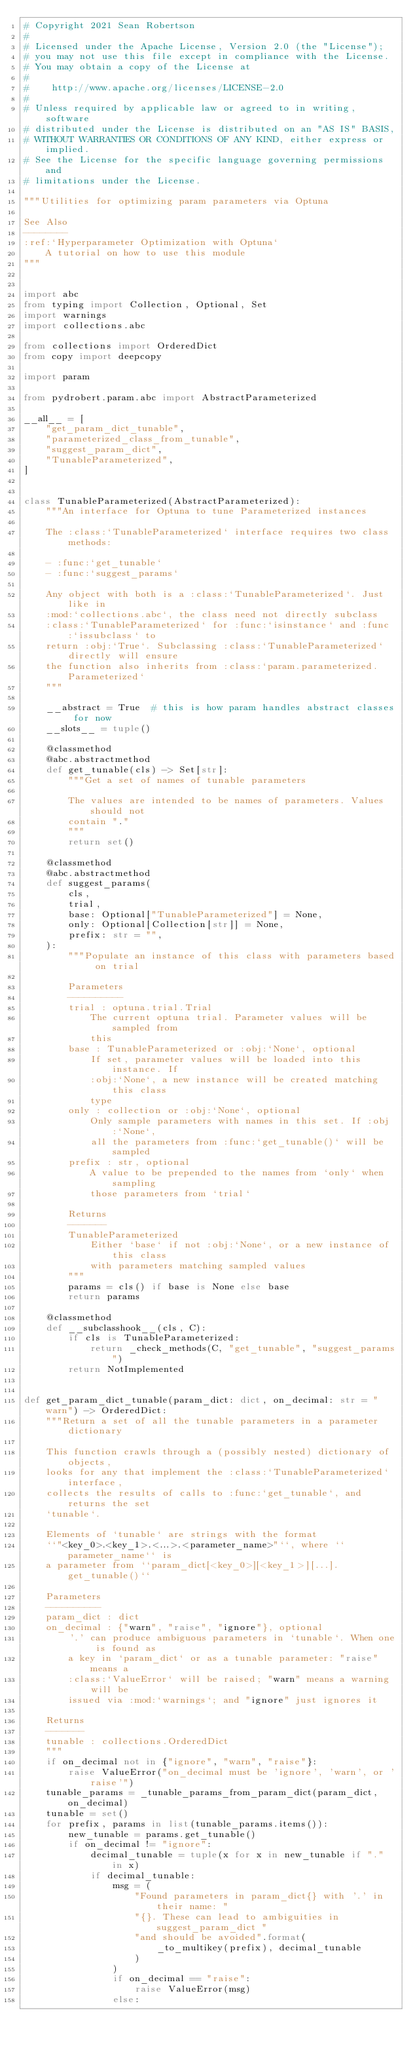Convert code to text. <code><loc_0><loc_0><loc_500><loc_500><_Python_># Copyright 2021 Sean Robertson
#
# Licensed under the Apache License, Version 2.0 (the "License");
# you may not use this file except in compliance with the License.
# You may obtain a copy of the License at
#
#    http://www.apache.org/licenses/LICENSE-2.0
#
# Unless required by applicable law or agreed to in writing, software
# distributed under the License is distributed on an "AS IS" BASIS,
# WITHOUT WARRANTIES OR CONDITIONS OF ANY KIND, either express or implied.
# See the License for the specific language governing permissions and
# limitations under the License.

"""Utilities for optimizing param parameters via Optuna

See Also
--------
:ref:`Hyperparameter Optimization with Optuna`
    A tutorial on how to use this module
"""


import abc
from typing import Collection, Optional, Set
import warnings
import collections.abc

from collections import OrderedDict
from copy import deepcopy

import param

from pydrobert.param.abc import AbstractParameterized

__all__ = [
    "get_param_dict_tunable",
    "parameterized_class_from_tunable",
    "suggest_param_dict",
    "TunableParameterized",
]


class TunableParameterized(AbstractParameterized):
    """An interface for Optuna to tune Parameterized instances

    The :class:`TunableParameterized` interface requires two class methods:

    - :func:`get_tunable`
    - :func:`suggest_params`

    Any object with both is a :class:`TunableParameterized`. Just like in
    :mod:`collections.abc`, the class need not directly subclass
    :class:`TunableParameterized` for :func:`isinstance` and :func:`issubclass` to
    return :obj:`True`. Subclassing :class:`TunableParameterized` directly will ensure
    the function also inherits from :class:`param.parameterized.Parameterized`
    """

    __abstract = True  # this is how param handles abstract classes for now
    __slots__ = tuple()

    @classmethod
    @abc.abstractmethod
    def get_tunable(cls) -> Set[str]:
        """Get a set of names of tunable parameters

        The values are intended to be names of parameters. Values should not
        contain "."
        """
        return set()

    @classmethod
    @abc.abstractmethod
    def suggest_params(
        cls,
        trial,
        base: Optional["TunableParameterized"] = None,
        only: Optional[Collection[str]] = None,
        prefix: str = "",
    ):
        """Populate an instance of this class with parameters based on trial

        Parameters
        ----------
        trial : optuna.trial.Trial
            The current optuna trial. Parameter values will be sampled from
            this
        base : TunableParameterized or :obj:`None`, optional
            If set, parameter values will be loaded into this instance. If
            :obj:`None`, a new instance will be created matching this class
            type
        only : collection or :obj:`None`, optional
            Only sample parameters with names in this set. If :obj:`None`,
            all the parameters from :func:`get_tunable()` will be sampled
        prefix : str, optional
            A value to be prepended to the names from `only` when sampling
            those parameters from `trial`

        Returns
        -------
        TunableParameterized
            Either `base` if not :obj:`None`, or a new instance of this class
            with parameters matching sampled values
        """
        params = cls() if base is None else base
        return params

    @classmethod
    def __subclasshook__(cls, C):
        if cls is TunableParameterized:
            return _check_methods(C, "get_tunable", "suggest_params")
        return NotImplemented


def get_param_dict_tunable(param_dict: dict, on_decimal: str = "warn") -> OrderedDict:
    """Return a set of all the tunable parameters in a parameter dictionary

    This function crawls through a (possibly nested) dictionary of objects,
    looks for any that implement the :class:`TunableParameterized` interface,
    collects the results of calls to :func:`get_tunable`, and returns the set
    `tunable`.

    Elements of `tunable` are strings with the format
    ``"<key_0>.<key_1>.<...>.<parameter_name>"``, where ``parameter_name`` is
    a parameter from ``param_dict[<key_0>][<key_1>][...].get_tunable()``

    Parameters
    ----------
    param_dict : dict
    on_decimal : {"warn", "raise", "ignore"}, optional
        '.' can produce ambiguous parameters in `tunable`. When one is found as
        a key in `param_dict` or as a tunable parameter: "raise" means a
        :class:`ValueError` will be raised; "warn" means a warning will be
        issued via :mod:`warnings`; and "ignore" just ignores it

    Returns
    -------
    tunable : collections.OrderedDict
    """
    if on_decimal not in {"ignore", "warn", "raise"}:
        raise ValueError("on_decimal must be 'ignore', 'warn', or 'raise'")
    tunable_params = _tunable_params_from_param_dict(param_dict, on_decimal)
    tunable = set()
    for prefix, params in list(tunable_params.items()):
        new_tunable = params.get_tunable()
        if on_decimal != "ignore":
            decimal_tunable = tuple(x for x in new_tunable if "." in x)
            if decimal_tunable:
                msg = (
                    "Found parameters in param_dict{} with '.' in their name: "
                    "{}. These can lead to ambiguities in suggest_param_dict "
                    "and should be avoided".format(
                        _to_multikey(prefix), decimal_tunable
                    )
                )
                if on_decimal == "raise":
                    raise ValueError(msg)
                else:</code> 